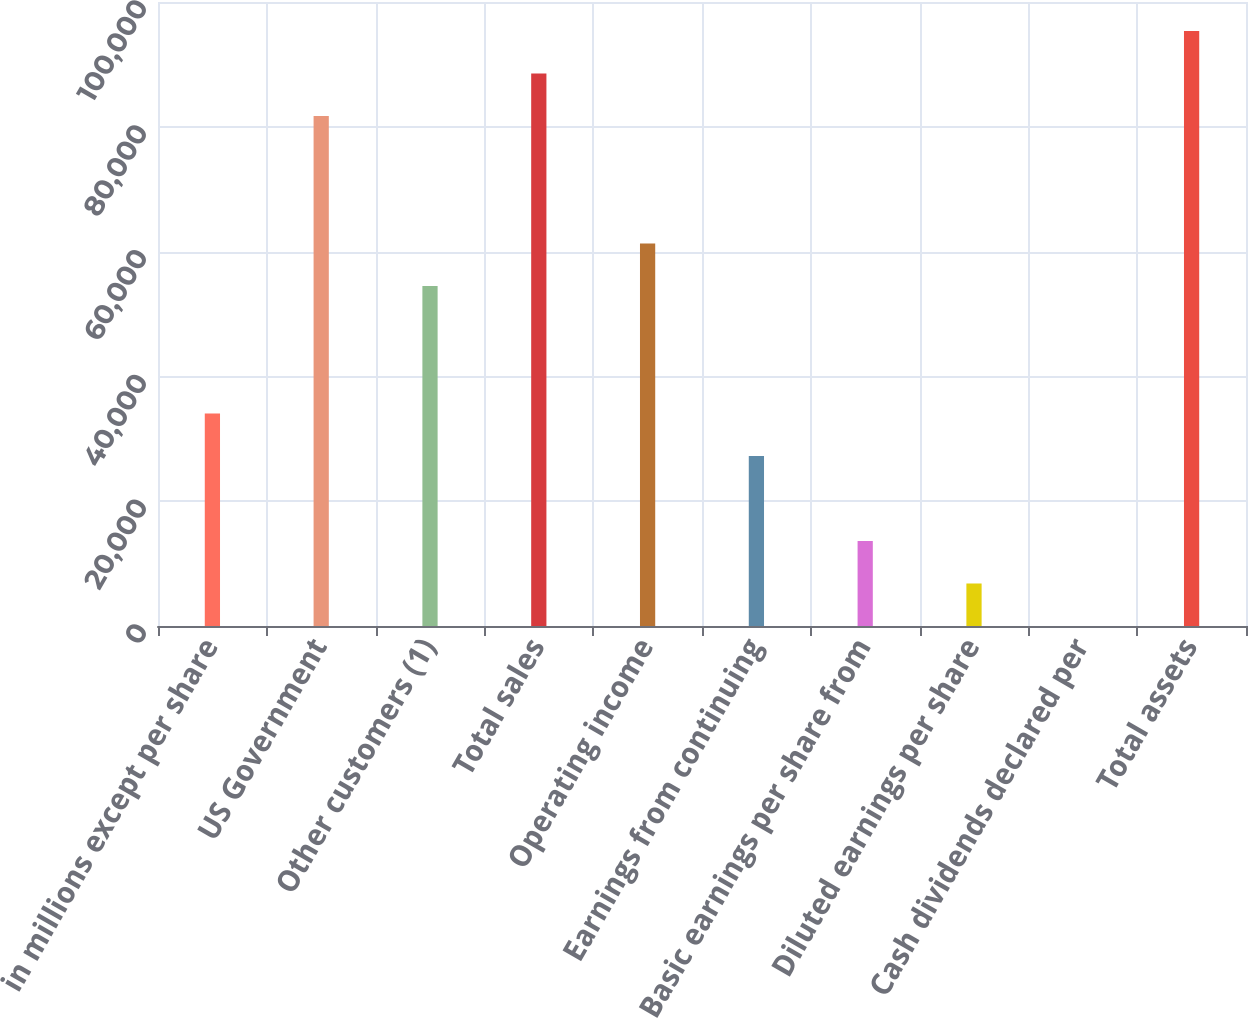<chart> <loc_0><loc_0><loc_500><loc_500><bar_chart><fcel>in millions except per share<fcel>US Government<fcel>Other customers (1)<fcel>Total sales<fcel>Operating income<fcel>Earnings from continuing<fcel>Basic earnings per share from<fcel>Diluted earnings per share<fcel>Cash dividends declared per<fcel>Total assets<nl><fcel>34051.1<fcel>81719.6<fcel>54480.4<fcel>88529.4<fcel>61290.2<fcel>27241.3<fcel>13621.7<fcel>6811.94<fcel>2.15<fcel>95339.2<nl></chart> 